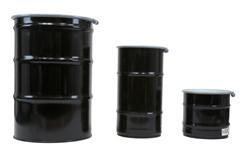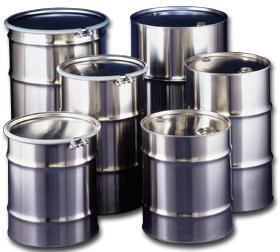The first image is the image on the left, the second image is the image on the right. Considering the images on both sides, is "The image on the right has a single canister while the image on the left has six." valid? Answer yes or no. No. The first image is the image on the left, the second image is the image on the right. For the images shown, is this caption "The right image contains exactly one black barrel." true? Answer yes or no. No. 